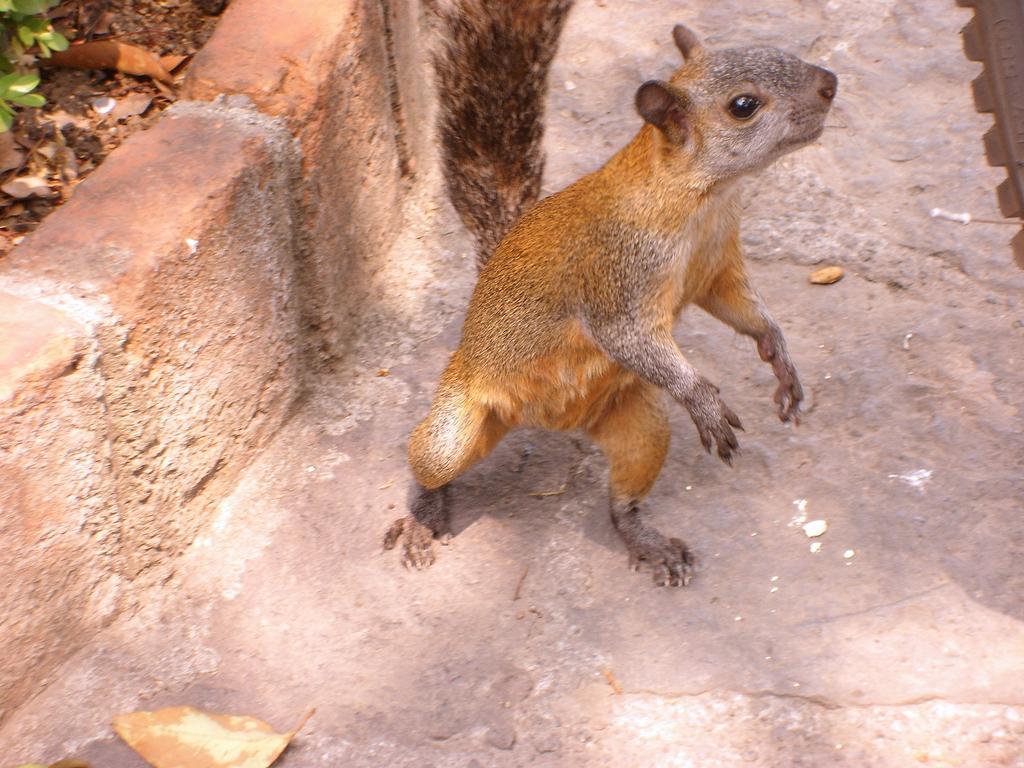Can you describe this image briefly? In this image I can see a squirrel on a surface. Beside the squirrel there are some bricks placed in a line and to side of it, we can have some green leafs visible. 